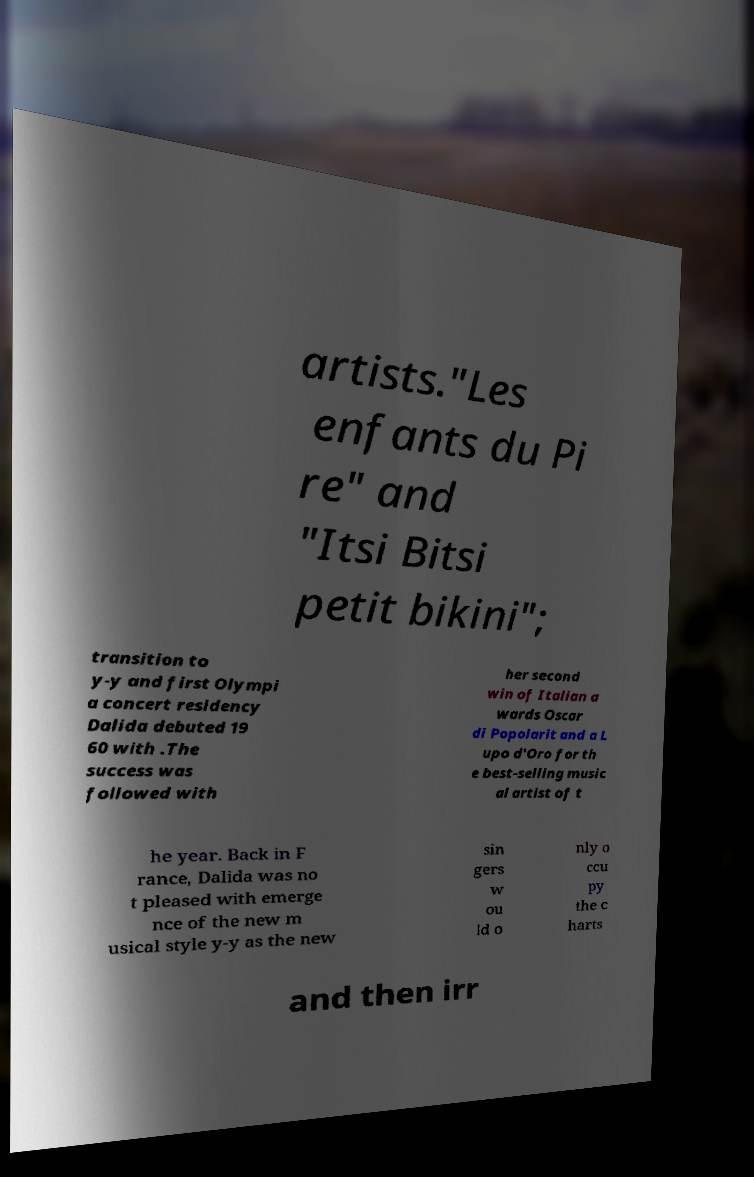What messages or text are displayed in this image? I need them in a readable, typed format. artists."Les enfants du Pi re" and "Itsi Bitsi petit bikini"; transition to y-y and first Olympi a concert residency Dalida debuted 19 60 with .The success was followed with her second win of Italian a wards Oscar di Popolarit and a L upo d'Oro for th e best-selling music al artist of t he year. Back in F rance, Dalida was no t pleased with emerge nce of the new m usical style y-y as the new sin gers w ou ld o nly o ccu py the c harts and then irr 